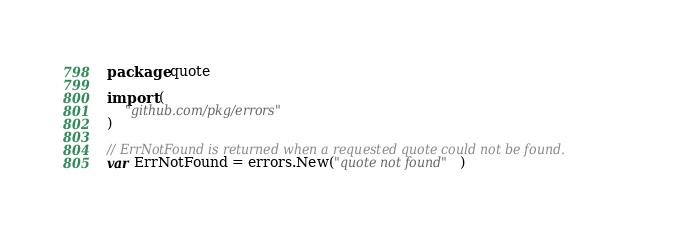Convert code to text. <code><loc_0><loc_0><loc_500><loc_500><_Go_>package quote

import (
	"github.com/pkg/errors"
)

// ErrNotFound is returned when a requested quote could not be found.
var ErrNotFound = errors.New("quote not found")
</code> 